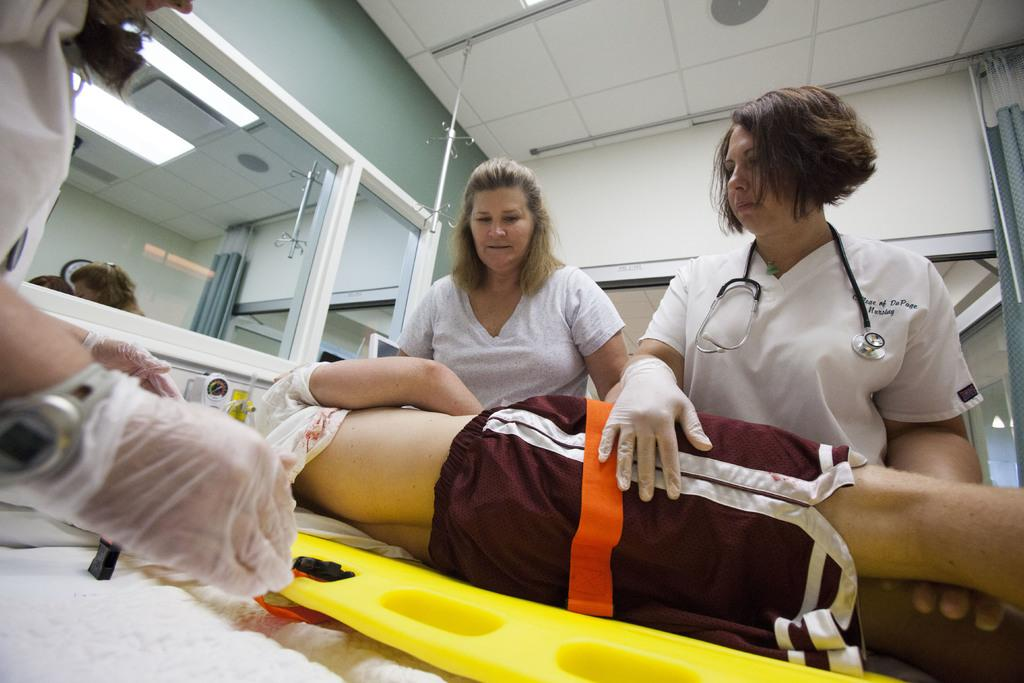What are the people in the image wearing? The people in the image are wearing clothes. What accessory can be seen on one of the people? There is a wristwatch in the image. What type of clothing is present in the image? There are gloves in the image. What object might be used for personal grooming or checking appearance? There is a mirror in the image. What source of illumination is visible in the image? There is a light in the image. What medical instrument is present in the image? There is a stethoscope in the image. What position is one of the people in the image? There is a person lying down in the image. What type of parcel is being delivered in the image? There is no parcel present in the image. What type of shade is being used to protect the people from the sun in the image? There is no shade present in the image. What type of pancake is being prepared in the image? There is being prepared in the image? 